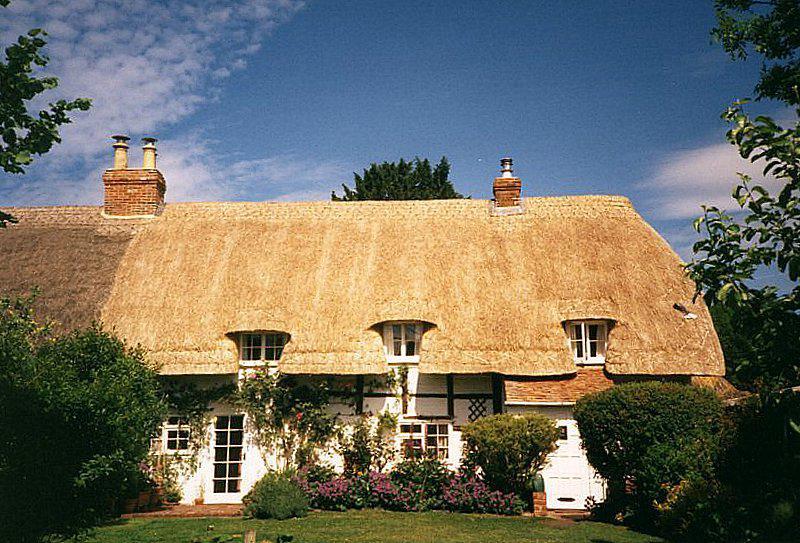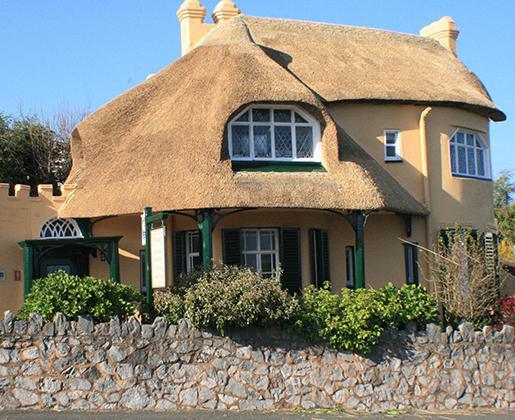The first image is the image on the left, the second image is the image on the right. Evaluate the accuracy of this statement regarding the images: "There are flowers by the house in one image, and a stone wall by the house in the other image.". Is it true? Answer yes or no. Yes. The first image is the image on the left, the second image is the image on the right. Considering the images on both sides, is "There is a small light brown building with a yellow straw looking roof free of any chimneys." valid? Answer yes or no. No. 